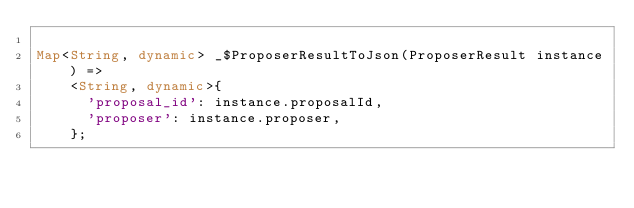<code> <loc_0><loc_0><loc_500><loc_500><_Dart_>
Map<String, dynamic> _$ProposerResultToJson(ProposerResult instance) =>
    <String, dynamic>{
      'proposal_id': instance.proposalId,
      'proposer': instance.proposer,
    };
</code> 